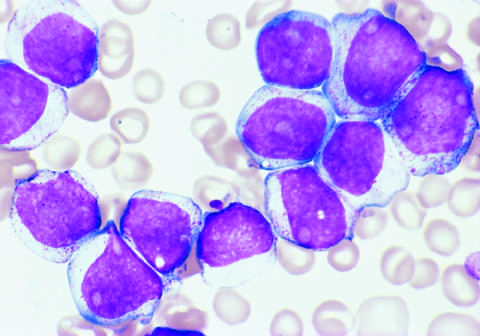re genes that encode several proteins involved in antigen processing positive for the stem cell marker cd34 and the myeloid lineage specific markers cd33 and cd15 subset?
Answer the question using a single word or phrase. No 